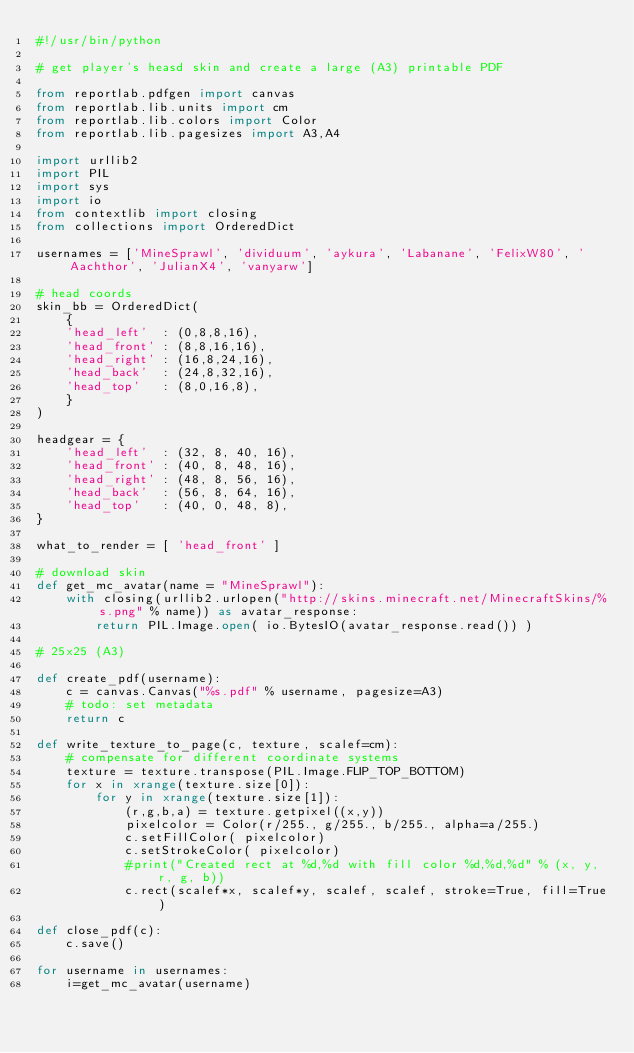Convert code to text. <code><loc_0><loc_0><loc_500><loc_500><_Python_>#!/usr/bin/python

# get player's heasd skin and create a large (A3) printable PDF

from reportlab.pdfgen import canvas
from reportlab.lib.units import cm
from reportlab.lib.colors import Color
from reportlab.lib.pagesizes import A3,A4

import urllib2
import PIL
import sys
import io
from contextlib import closing
from collections import OrderedDict

usernames = ['MineSprawl', 'dividuum', 'aykura', 'Labanane', 'FelixW80', 'Aachthor', 'JulianX4', 'vanyarw']

# head coords
skin_bb = OrderedDict(
    {
    'head_left'  : (0,8,8,16),
    'head_front' : (8,8,16,16),
    'head_right' : (16,8,24,16),
    'head_back'  : (24,8,32,16),
    'head_top'   : (8,0,16,8),
    }
)

headgear = {
    'head_left'  : (32, 8, 40, 16),
    'head_front' : (40, 8, 48, 16),
    'head_right' : (48, 8, 56, 16),
    'head_back'  : (56, 8, 64, 16),
    'head_top'   : (40, 0, 48, 8),
}

what_to_render = [ 'head_front' ]

# download skin
def get_mc_avatar(name = "MineSprawl"):
    with closing(urllib2.urlopen("http://skins.minecraft.net/MinecraftSkins/%s.png" % name)) as avatar_response:
        return PIL.Image.open( io.BytesIO(avatar_response.read()) )

# 25x25 (A3)

def create_pdf(username):
    c = canvas.Canvas("%s.pdf" % username, pagesize=A3)
    # todo: set metadata
    return c

def write_texture_to_page(c, texture, scalef=cm):
    # compensate for different coordinate systems
    texture = texture.transpose(PIL.Image.FLIP_TOP_BOTTOM)
    for x in xrange(texture.size[0]):
        for y in xrange(texture.size[1]):
            (r,g,b,a) = texture.getpixel((x,y))
            pixelcolor = Color(r/255., g/255., b/255., alpha=a/255.)
            c.setFillColor( pixelcolor)
            c.setStrokeColor( pixelcolor)
            #print("Created rect at %d,%d with fill color %d,%d,%d" % (x, y, r, g, b))
            c.rect(scalef*x, scalef*y, scalef, scalef, stroke=True, fill=True)

def close_pdf(c):
    c.save()

for username in usernames:
    i=get_mc_avatar(username)</code> 